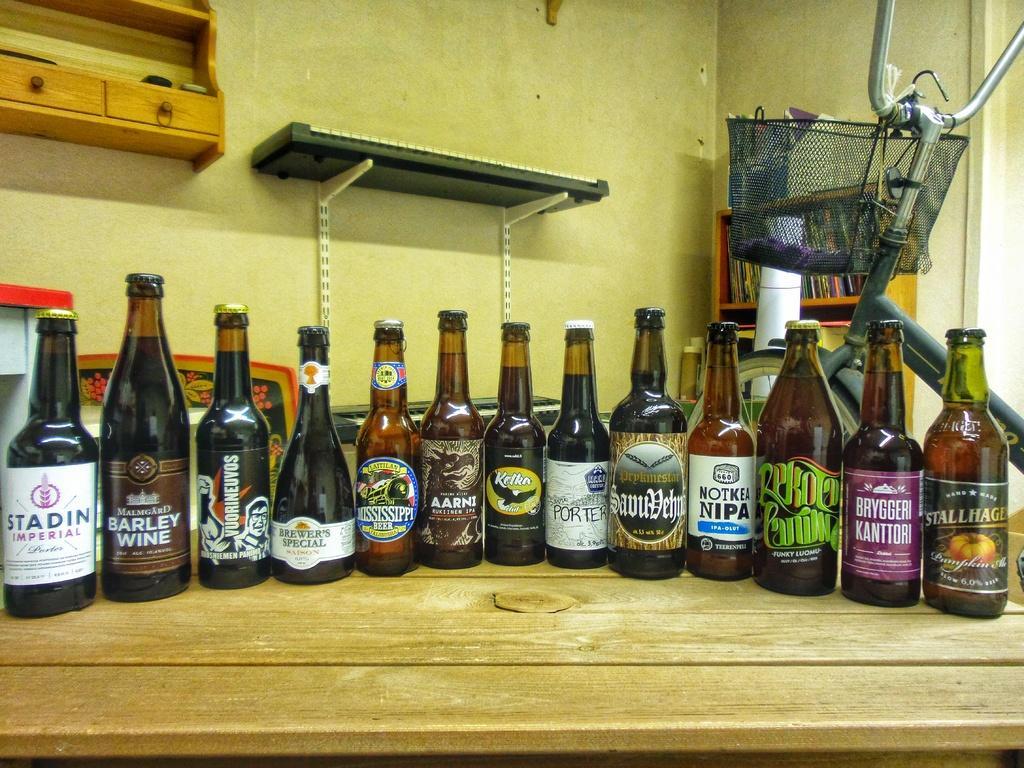Can you describe this image briefly? On this table there are bottles and tray. Far there is a bicycle with basket. This rack is filled with books. 